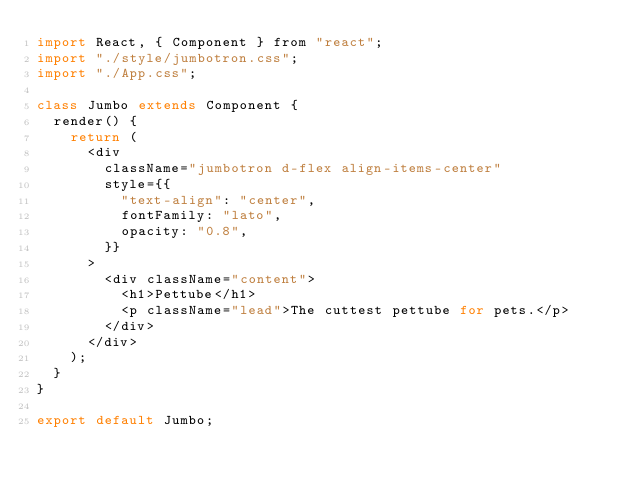<code> <loc_0><loc_0><loc_500><loc_500><_JavaScript_>import React, { Component } from "react";
import "./style/jumbotron.css";
import "./App.css";

class Jumbo extends Component {
  render() {
    return (
      <div
        className="jumbotron d-flex align-items-center"
        style={{
          "text-align": "center",
          fontFamily: "lato",
          opacity: "0.8",
        }}
      >
        <div className="content">
          <h1>Pettube</h1>
          <p className="lead">The cuttest pettube for pets.</p>
        </div>
      </div>
    );
  }
}

export default Jumbo;
</code> 